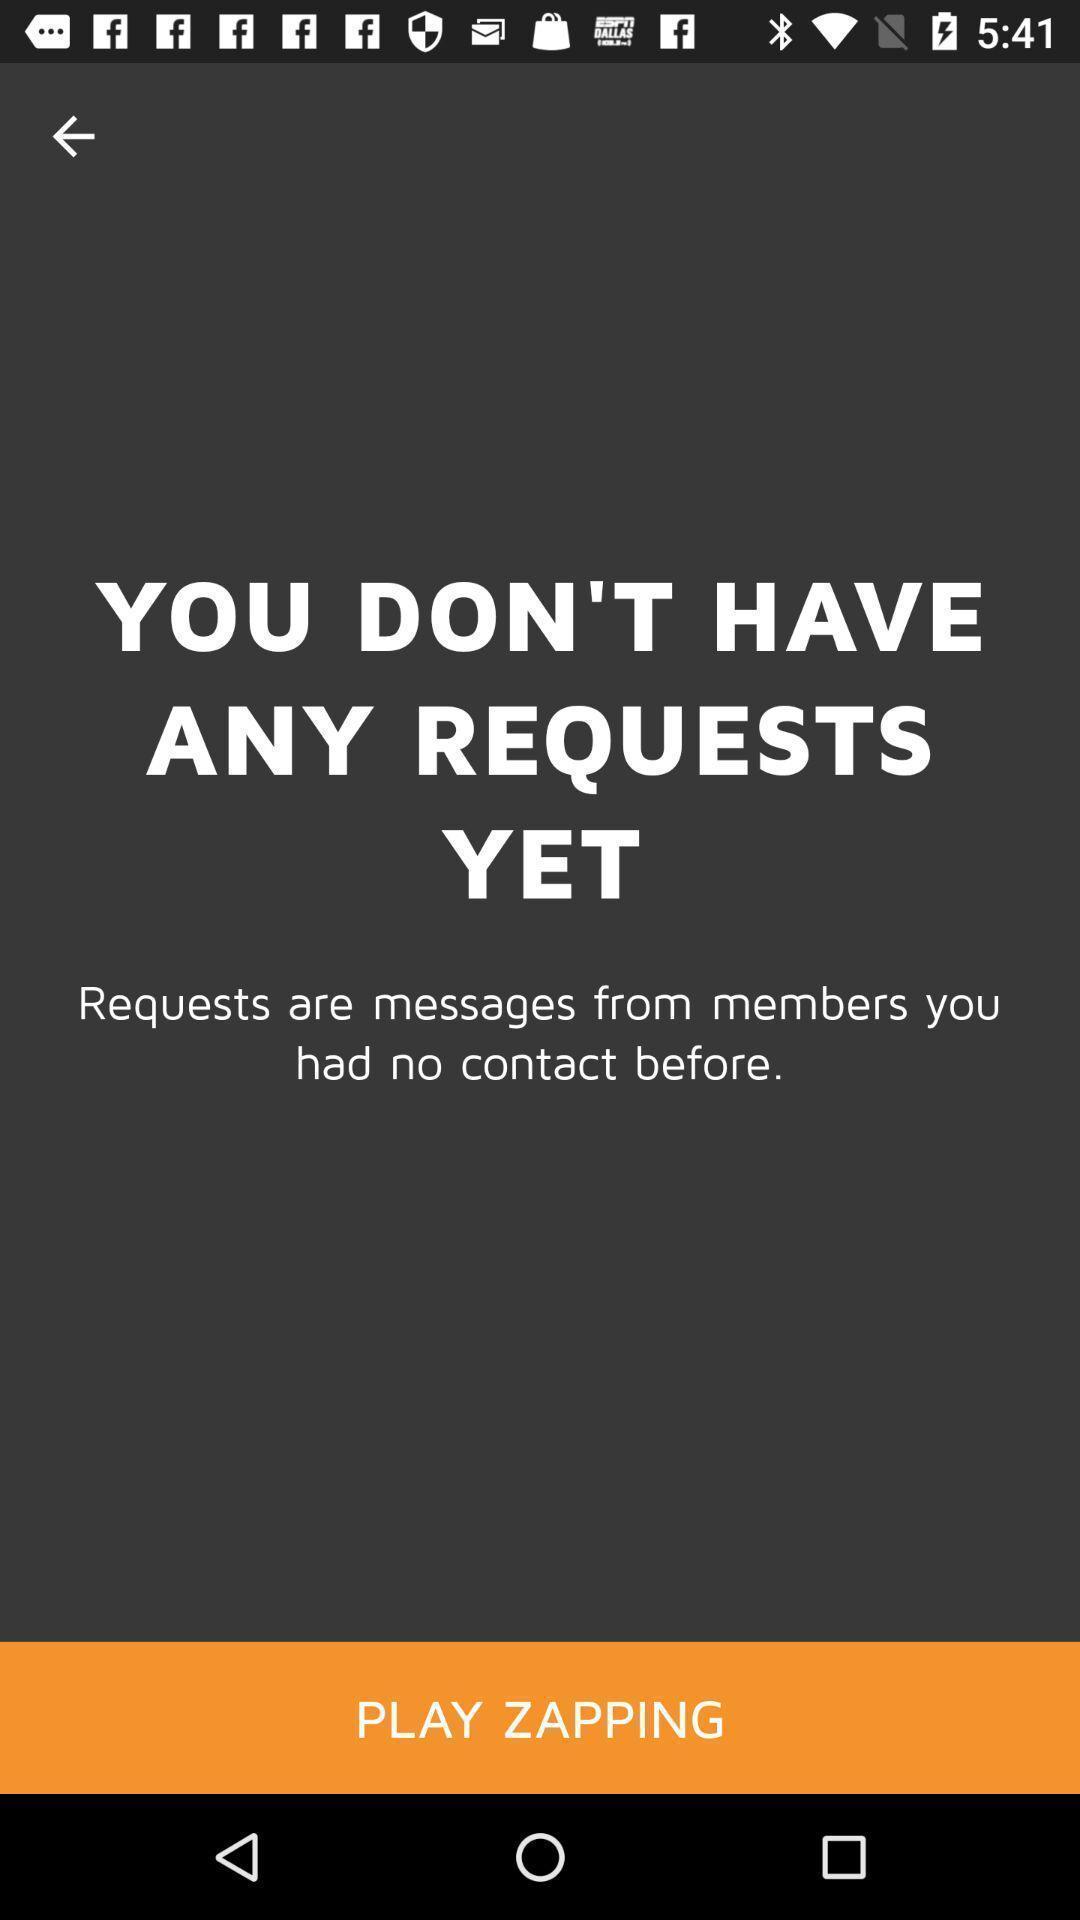Describe the key features of this screenshot. Window displaying a lesbian dating app. 